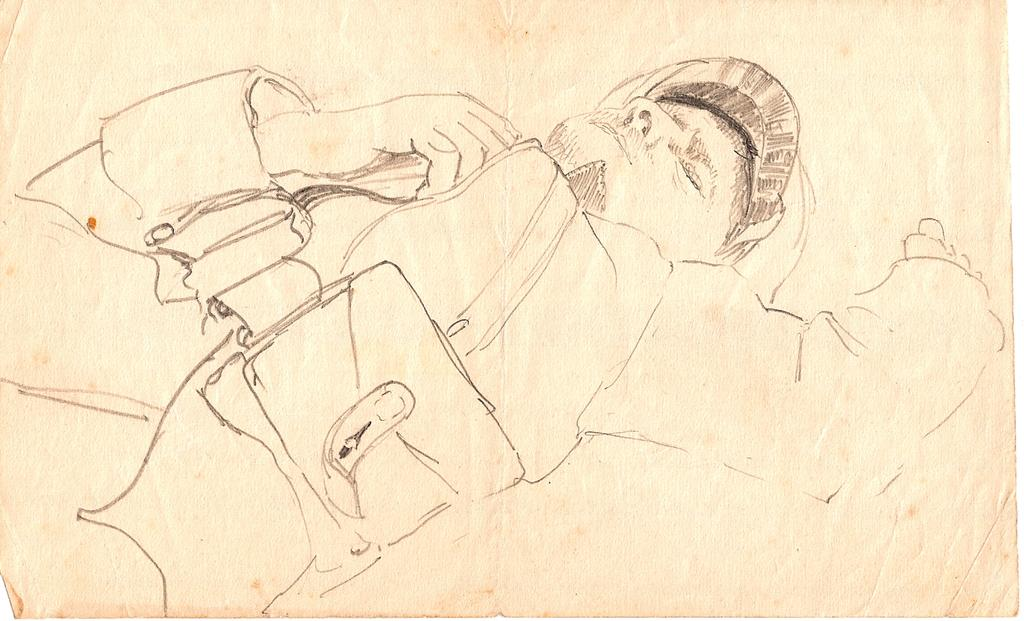What is depicted on the paper in the image? The paper contains a sketch of a person. What type of material is the paper made of? The facts provided do not specify the material of the paper, but it is likely to be made of paper or a similar material. How many passengers are visible in the sketch on the paper? There is no reference to passengers in the image, as it only contains a sketch of a person. 